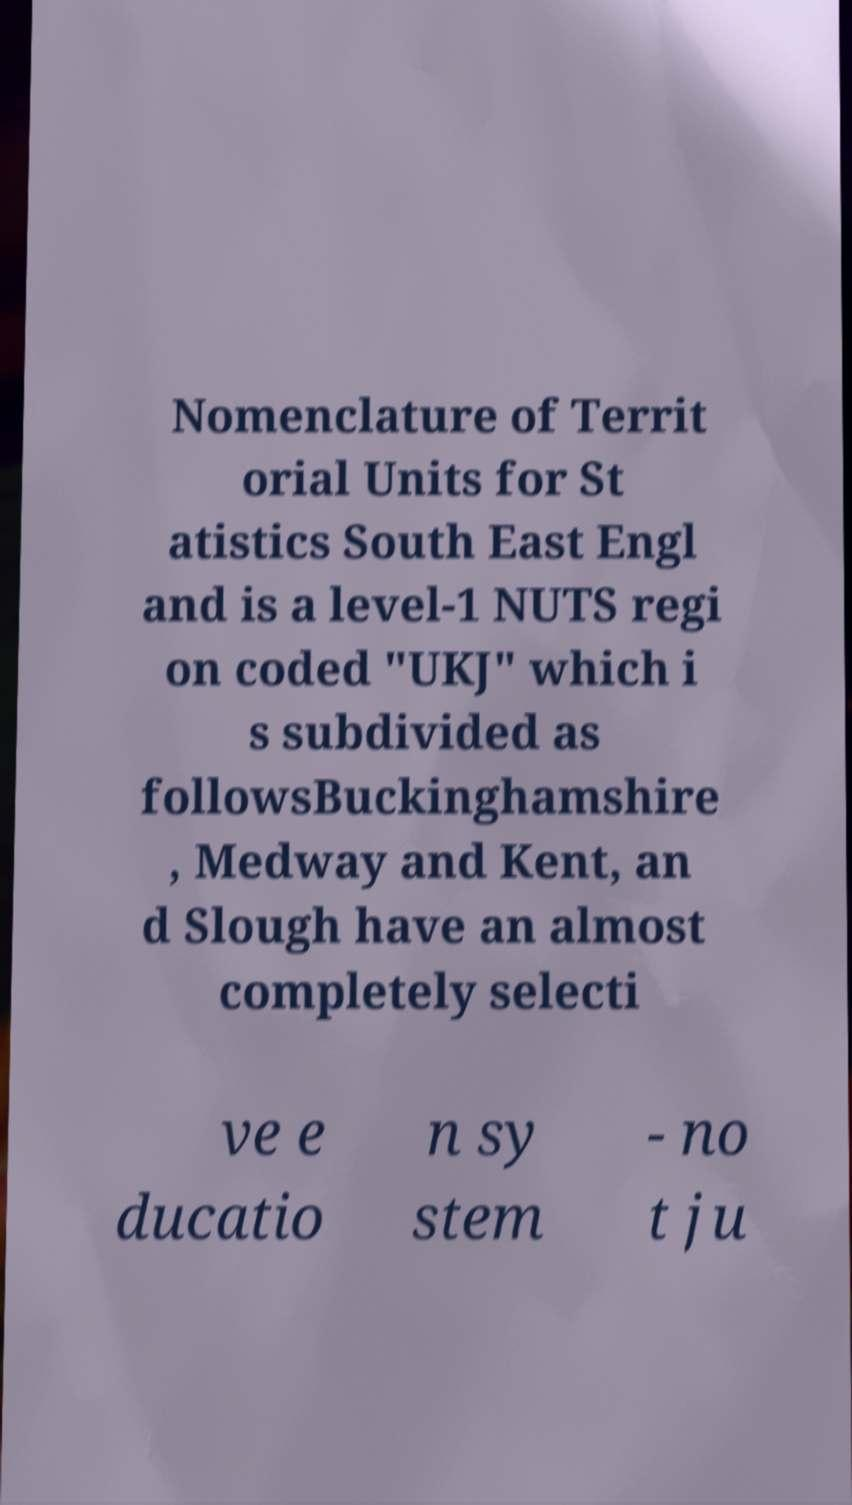Could you assist in decoding the text presented in this image and type it out clearly? Nomenclature of Territ orial Units for St atistics South East Engl and is a level-1 NUTS regi on coded "UKJ" which i s subdivided as followsBuckinghamshire , Medway and Kent, an d Slough have an almost completely selecti ve e ducatio n sy stem - no t ju 